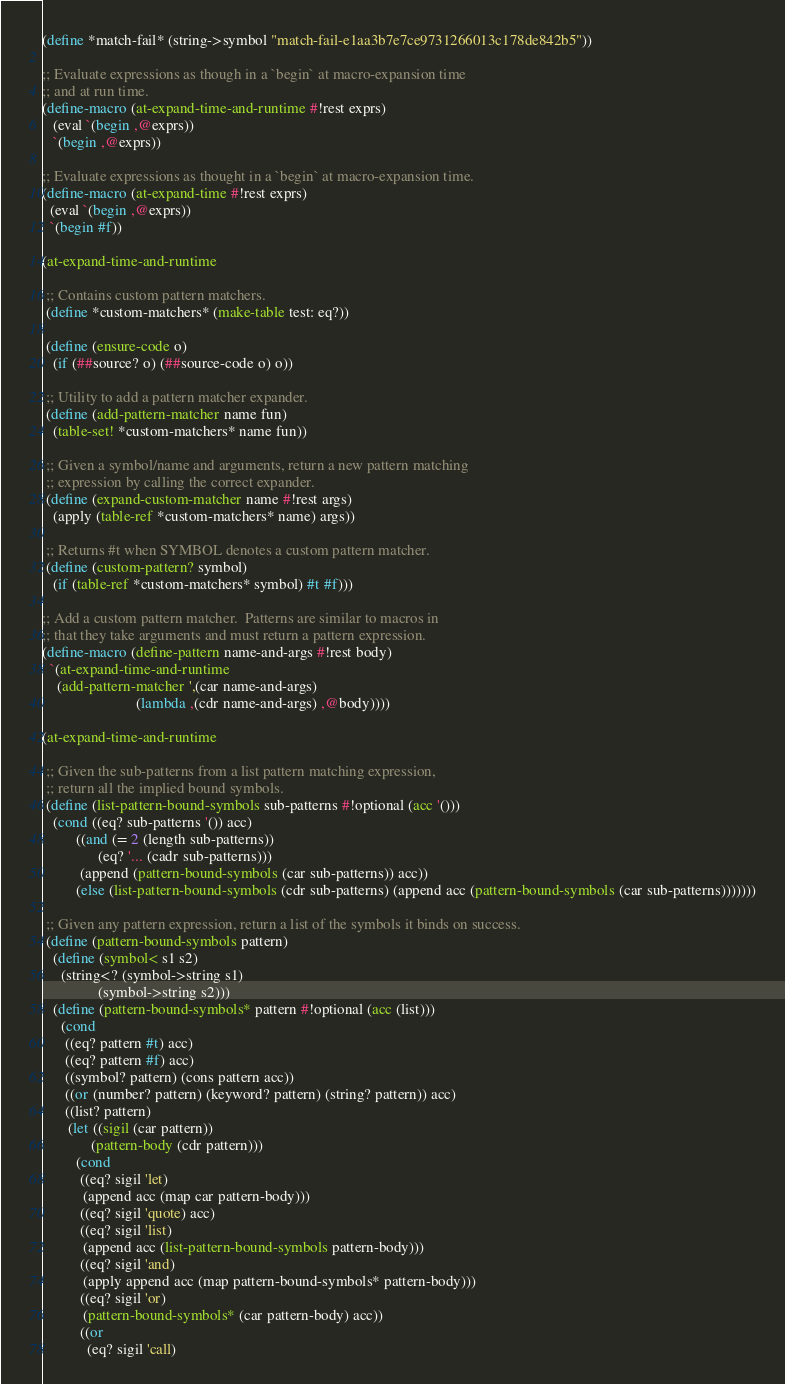<code> <loc_0><loc_0><loc_500><loc_500><_Scheme_>(define *match-fail* (string->symbol "match-fail-e1aa3b7e7ce9731266013c178de842b5"))

;; Evaluate expressions as though in a `begin` at macro-expansion time
;; and at run time.
(define-macro (at-expand-time-and-runtime #!rest exprs)
   (eval `(begin ,@exprs))
   `(begin ,@exprs))

;; Evaluate expressions as thought in a `begin` at macro-expansion time.
(define-macro (at-expand-time #!rest exprs)
  (eval `(begin ,@exprs))
  `(begin #f))

(at-expand-time-and-runtime

 ;; Contains custom pattern matchers. 
 (define *custom-matchers* (make-table test: eq?))

 (define (ensure-code o)
   (if (##source? o) (##source-code o) o))

 ;; Utility to add a pattern matcher expander. 
 (define (add-pattern-matcher name fun)
   (table-set! *custom-matchers* name fun))

 ;; Given a symbol/name and arguments, return a new pattern matching
 ;; expression by calling the correct expander.
 (define (expand-custom-matcher name #!rest args)
   (apply (table-ref *custom-matchers* name) args))

 ;; Returns #t when SYMBOL denotes a custom pattern matcher.
 (define (custom-pattern? symbol)
   (if (table-ref *custom-matchers* symbol) #t #f)))

;; Add a custom pattern matcher.  Patterns are similar to macros in
;; that they take arguments and must return a pattern expression.
(define-macro (define-pattern name-and-args #!rest body)
  `(at-expand-time-and-runtime
	(add-pattern-matcher ',(car name-and-args)
						 (lambda ,(cdr name-and-args) ,@body))))

(at-expand-time-and-runtime 

 ;; Given the sub-patterns from a list pattern matching expression,
 ;; return all the implied bound symbols.
 (define (list-pattern-bound-symbols sub-patterns #!optional (acc '()))
   (cond ((eq? sub-patterns '()) acc)
		 ((and (= 2 (length sub-patterns))
			   (eq? '... (cadr sub-patterns)))
		  (append (pattern-bound-symbols (car sub-patterns)) acc))
		 (else (list-pattern-bound-symbols (cdr sub-patterns) (append acc (pattern-bound-symbols (car sub-patterns)))))))

 ;; Given any pattern expression, return a list of the symbols it binds on success.
 (define (pattern-bound-symbols pattern) 
   (define (symbol< s1 s2)
	 (string<? (symbol->string s1)
			   (symbol->string s2)))
   (define (pattern-bound-symbols* pattern #!optional (acc (list)))
	 (cond
	  ((eq? pattern #t) acc)
	  ((eq? pattern #f) acc)
	  ((symbol? pattern) (cons pattern acc))
	  ((or (number? pattern) (keyword? pattern) (string? pattern)) acc)
	  ((list? pattern)
	   (let ((sigil (car pattern))
			 (pattern-body (cdr pattern)))
		 (cond 
		  ((eq? sigil 'let)
		   (append acc (map car pattern-body)))
		  ((eq? sigil 'quote) acc)
		  ((eq? sigil 'list)
		   (append acc (list-pattern-bound-symbols pattern-body)))
		  ((eq? sigil 'and)
		   (apply append acc (map pattern-bound-symbols* pattern-body)))
		  ((eq? sigil 'or)
		   (pattern-bound-symbols* (car pattern-body) acc))
		  ((or 
			(eq? sigil 'call)</code> 